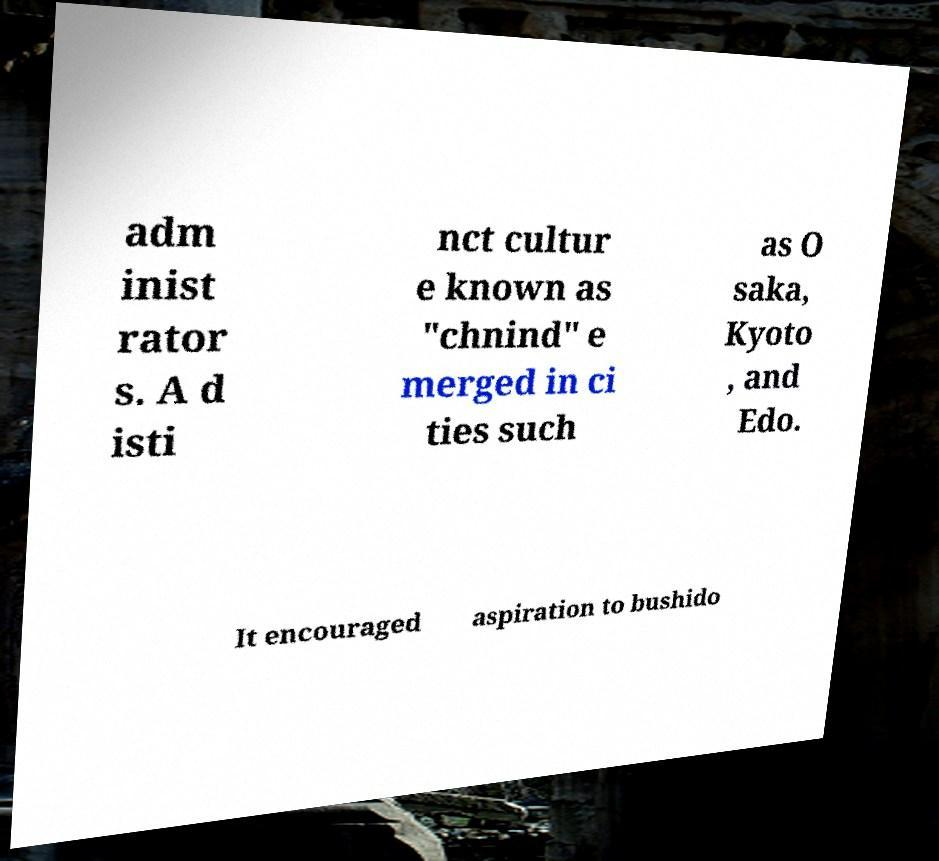For documentation purposes, I need the text within this image transcribed. Could you provide that? adm inist rator s. A d isti nct cultur e known as "chnind" e merged in ci ties such as O saka, Kyoto , and Edo. It encouraged aspiration to bushido 